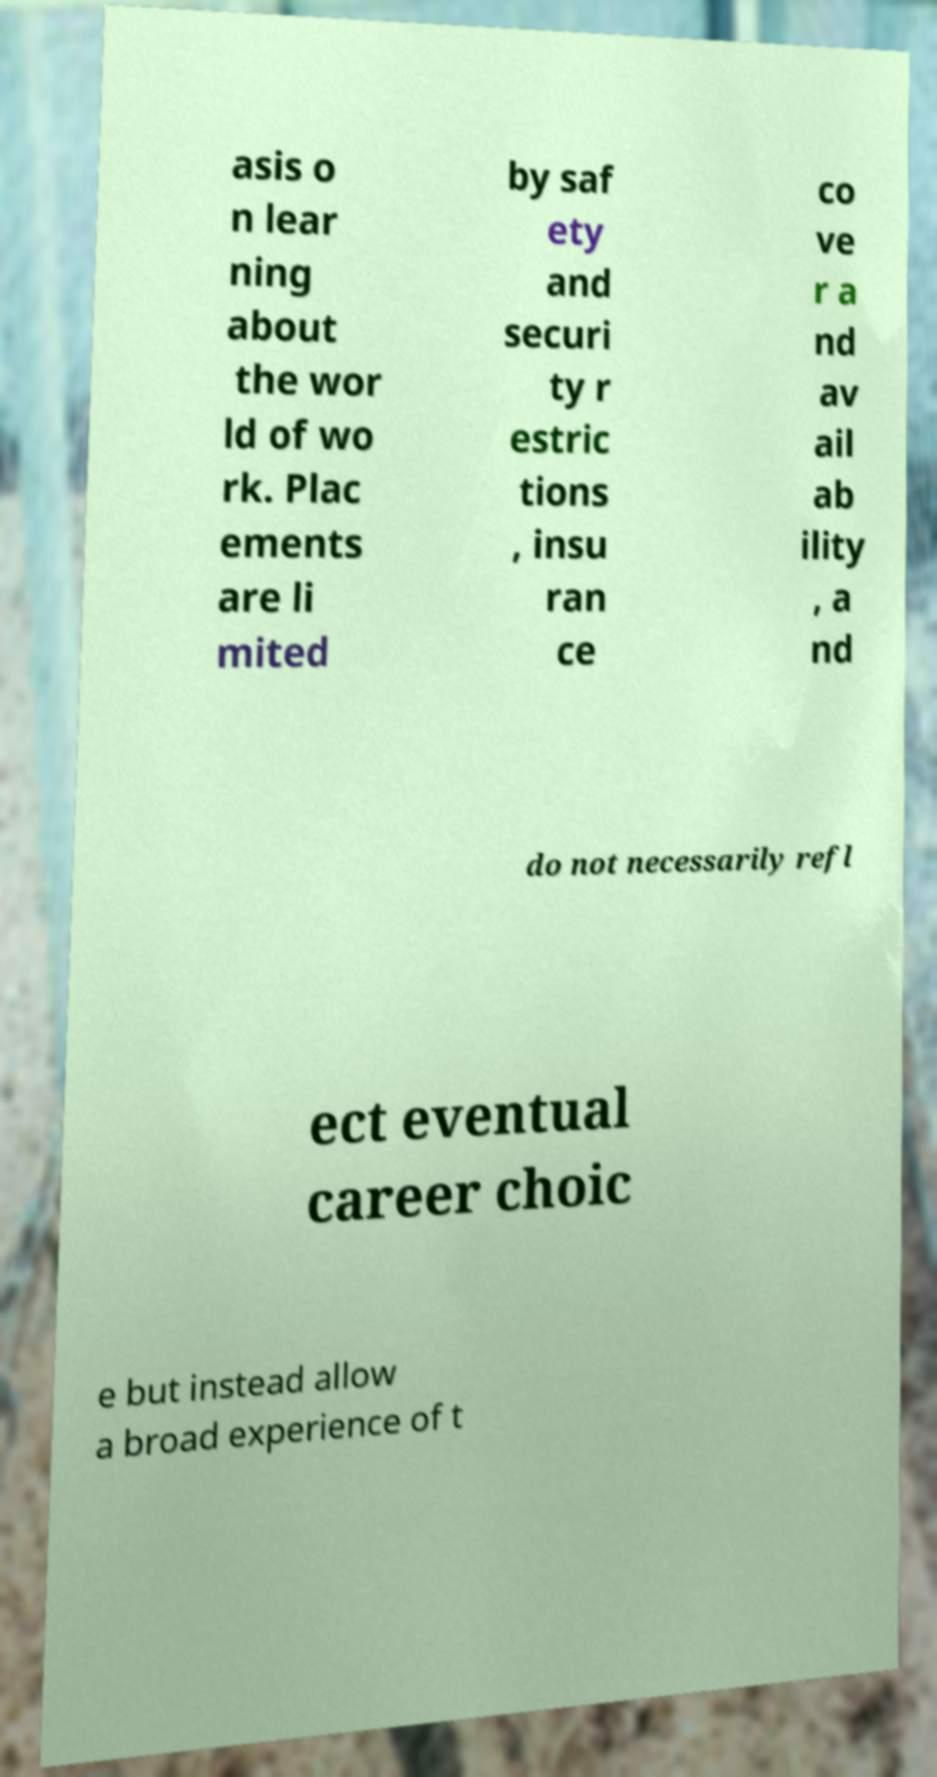Please identify and transcribe the text found in this image. asis o n lear ning about the wor ld of wo rk. Plac ements are li mited by saf ety and securi ty r estric tions , insu ran ce co ve r a nd av ail ab ility , a nd do not necessarily refl ect eventual career choic e but instead allow a broad experience of t 